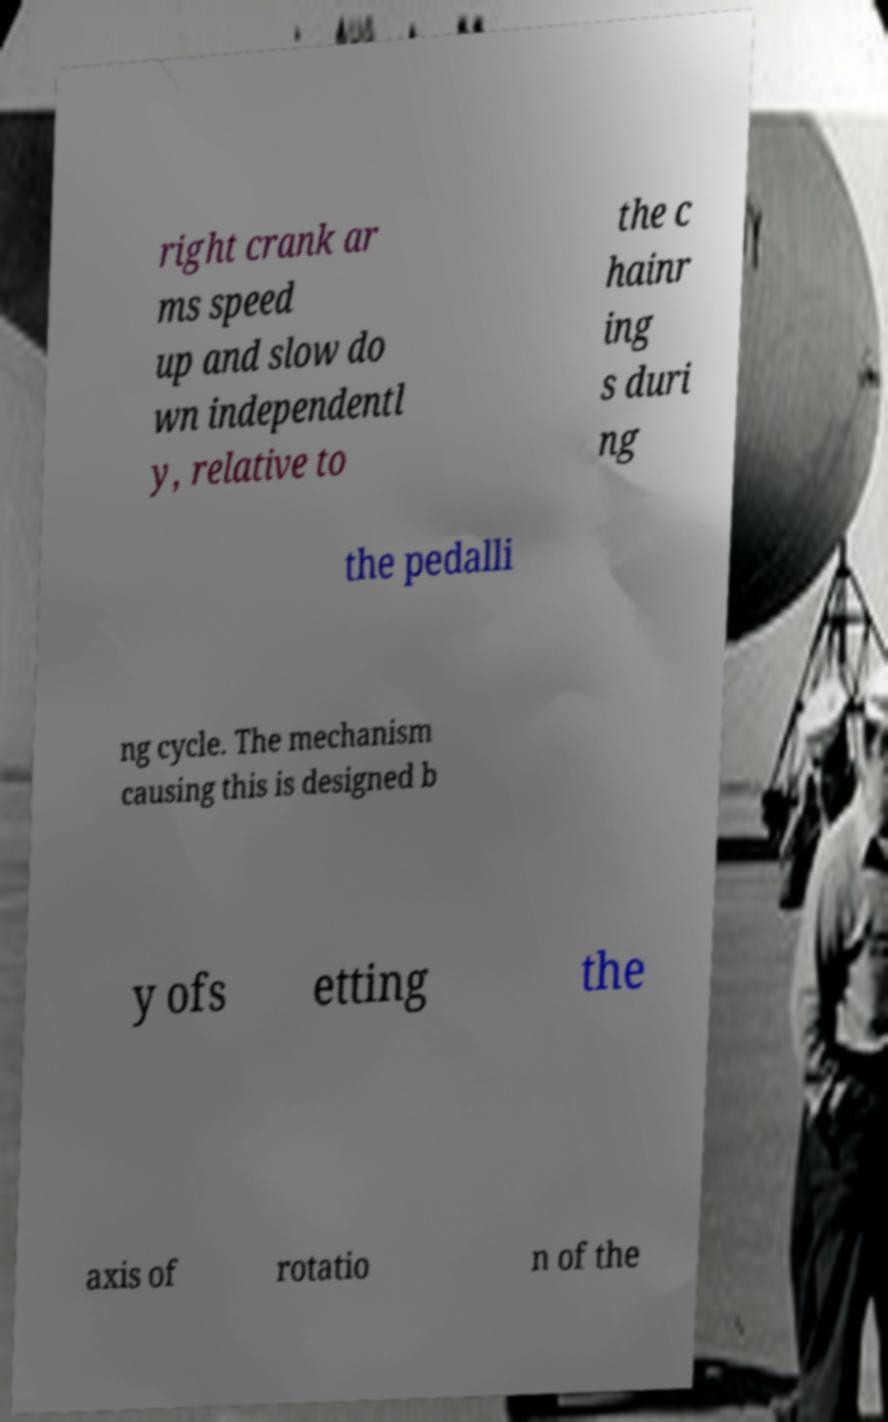I need the written content from this picture converted into text. Can you do that? right crank ar ms speed up and slow do wn independentl y, relative to the c hainr ing s duri ng the pedalli ng cycle. The mechanism causing this is designed b y ofs etting the axis of rotatio n of the 